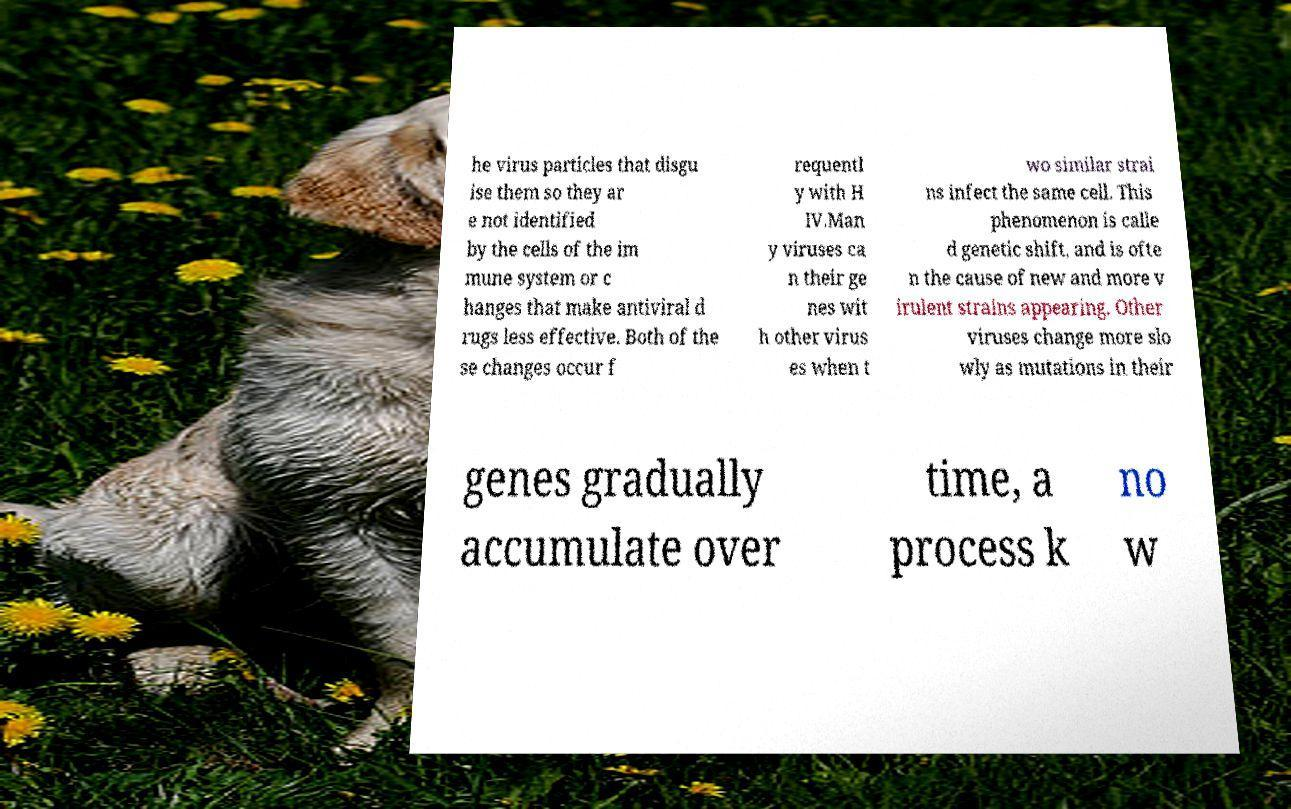Please identify and transcribe the text found in this image. he virus particles that disgu ise them so they ar e not identified by the cells of the im mune system or c hanges that make antiviral d rugs less effective. Both of the se changes occur f requentl y with H IV.Man y viruses ca n their ge nes wit h other virus es when t wo similar strai ns infect the same cell. This phenomenon is calle d genetic shift, and is ofte n the cause of new and more v irulent strains appearing. Other viruses change more slo wly as mutations in their genes gradually accumulate over time, a process k no w 